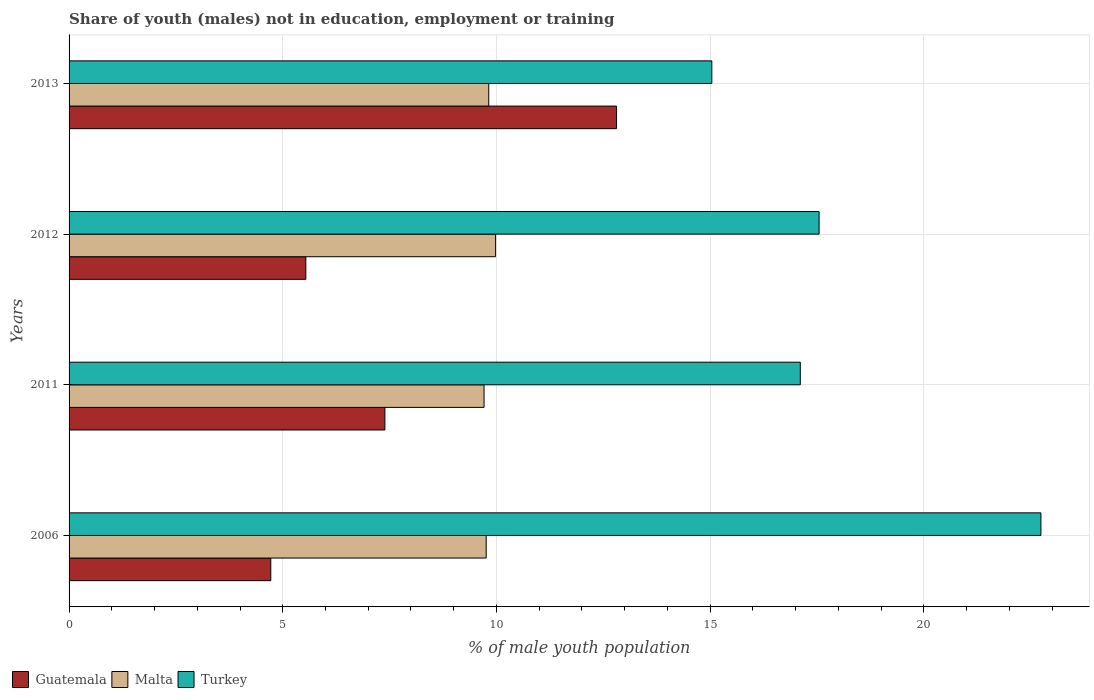How many different coloured bars are there?
Provide a succinct answer. 3. How many groups of bars are there?
Offer a very short reply. 4. What is the label of the 1st group of bars from the top?
Give a very brief answer. 2013. In how many cases, is the number of bars for a given year not equal to the number of legend labels?
Make the answer very short. 0. What is the percentage of unemployed males population in in Guatemala in 2006?
Your answer should be very brief. 4.72. Across all years, what is the maximum percentage of unemployed males population in in Guatemala?
Offer a terse response. 12.81. Across all years, what is the minimum percentage of unemployed males population in in Guatemala?
Ensure brevity in your answer.  4.72. In which year was the percentage of unemployed males population in in Turkey minimum?
Your answer should be very brief. 2013. What is the total percentage of unemployed males population in in Guatemala in the graph?
Make the answer very short. 30.46. What is the difference between the percentage of unemployed males population in in Turkey in 2011 and that in 2013?
Offer a very short reply. 2.07. What is the difference between the percentage of unemployed males population in in Turkey in 2011 and the percentage of unemployed males population in in Guatemala in 2013?
Ensure brevity in your answer.  4.3. What is the average percentage of unemployed males population in in Turkey per year?
Offer a very short reply. 18.11. In the year 2012, what is the difference between the percentage of unemployed males population in in Malta and percentage of unemployed males population in in Guatemala?
Give a very brief answer. 4.44. In how many years, is the percentage of unemployed males population in in Malta greater than 8 %?
Ensure brevity in your answer.  4. What is the ratio of the percentage of unemployed males population in in Turkey in 2011 to that in 2012?
Offer a very short reply. 0.97. What is the difference between the highest and the second highest percentage of unemployed males population in in Guatemala?
Your answer should be very brief. 5.42. What is the difference between the highest and the lowest percentage of unemployed males population in in Malta?
Offer a terse response. 0.27. In how many years, is the percentage of unemployed males population in in Malta greater than the average percentage of unemployed males population in in Malta taken over all years?
Offer a very short reply. 2. What does the 2nd bar from the top in 2012 represents?
Provide a short and direct response. Malta. What does the 2nd bar from the bottom in 2013 represents?
Your response must be concise. Malta. Is it the case that in every year, the sum of the percentage of unemployed males population in in Malta and percentage of unemployed males population in in Turkey is greater than the percentage of unemployed males population in in Guatemala?
Give a very brief answer. Yes. How many bars are there?
Provide a succinct answer. 12. What is the difference between two consecutive major ticks on the X-axis?
Your answer should be very brief. 5. Are the values on the major ticks of X-axis written in scientific E-notation?
Provide a succinct answer. No. Does the graph contain grids?
Keep it short and to the point. Yes. How many legend labels are there?
Your answer should be compact. 3. How are the legend labels stacked?
Offer a terse response. Horizontal. What is the title of the graph?
Your answer should be very brief. Share of youth (males) not in education, employment or training. Does "Togo" appear as one of the legend labels in the graph?
Provide a short and direct response. No. What is the label or title of the X-axis?
Your response must be concise. % of male youth population. What is the label or title of the Y-axis?
Offer a very short reply. Years. What is the % of male youth population of Guatemala in 2006?
Offer a terse response. 4.72. What is the % of male youth population in Malta in 2006?
Your response must be concise. 9.76. What is the % of male youth population in Turkey in 2006?
Provide a short and direct response. 22.74. What is the % of male youth population of Guatemala in 2011?
Your answer should be compact. 7.39. What is the % of male youth population in Malta in 2011?
Offer a terse response. 9.71. What is the % of male youth population of Turkey in 2011?
Provide a succinct answer. 17.11. What is the % of male youth population of Guatemala in 2012?
Provide a succinct answer. 5.54. What is the % of male youth population of Malta in 2012?
Give a very brief answer. 9.98. What is the % of male youth population in Turkey in 2012?
Provide a short and direct response. 17.55. What is the % of male youth population in Guatemala in 2013?
Your answer should be very brief. 12.81. What is the % of male youth population of Malta in 2013?
Keep it short and to the point. 9.82. What is the % of male youth population of Turkey in 2013?
Offer a terse response. 15.04. Across all years, what is the maximum % of male youth population of Guatemala?
Your answer should be very brief. 12.81. Across all years, what is the maximum % of male youth population of Malta?
Your response must be concise. 9.98. Across all years, what is the maximum % of male youth population in Turkey?
Make the answer very short. 22.74. Across all years, what is the minimum % of male youth population of Guatemala?
Offer a very short reply. 4.72. Across all years, what is the minimum % of male youth population of Malta?
Make the answer very short. 9.71. Across all years, what is the minimum % of male youth population of Turkey?
Keep it short and to the point. 15.04. What is the total % of male youth population of Guatemala in the graph?
Your response must be concise. 30.46. What is the total % of male youth population of Malta in the graph?
Ensure brevity in your answer.  39.27. What is the total % of male youth population of Turkey in the graph?
Your response must be concise. 72.44. What is the difference between the % of male youth population of Guatemala in 2006 and that in 2011?
Your answer should be compact. -2.67. What is the difference between the % of male youth population of Turkey in 2006 and that in 2011?
Give a very brief answer. 5.63. What is the difference between the % of male youth population of Guatemala in 2006 and that in 2012?
Your response must be concise. -0.82. What is the difference between the % of male youth population of Malta in 2006 and that in 2012?
Give a very brief answer. -0.22. What is the difference between the % of male youth population in Turkey in 2006 and that in 2012?
Make the answer very short. 5.19. What is the difference between the % of male youth population of Guatemala in 2006 and that in 2013?
Provide a short and direct response. -8.09. What is the difference between the % of male youth population in Malta in 2006 and that in 2013?
Your answer should be very brief. -0.06. What is the difference between the % of male youth population in Turkey in 2006 and that in 2013?
Give a very brief answer. 7.7. What is the difference between the % of male youth population of Guatemala in 2011 and that in 2012?
Make the answer very short. 1.85. What is the difference between the % of male youth population of Malta in 2011 and that in 2012?
Make the answer very short. -0.27. What is the difference between the % of male youth population of Turkey in 2011 and that in 2012?
Give a very brief answer. -0.44. What is the difference between the % of male youth population of Guatemala in 2011 and that in 2013?
Provide a succinct answer. -5.42. What is the difference between the % of male youth population of Malta in 2011 and that in 2013?
Give a very brief answer. -0.11. What is the difference between the % of male youth population in Turkey in 2011 and that in 2013?
Your response must be concise. 2.07. What is the difference between the % of male youth population in Guatemala in 2012 and that in 2013?
Offer a very short reply. -7.27. What is the difference between the % of male youth population of Malta in 2012 and that in 2013?
Give a very brief answer. 0.16. What is the difference between the % of male youth population in Turkey in 2012 and that in 2013?
Offer a terse response. 2.51. What is the difference between the % of male youth population of Guatemala in 2006 and the % of male youth population of Malta in 2011?
Make the answer very short. -4.99. What is the difference between the % of male youth population in Guatemala in 2006 and the % of male youth population in Turkey in 2011?
Ensure brevity in your answer.  -12.39. What is the difference between the % of male youth population of Malta in 2006 and the % of male youth population of Turkey in 2011?
Offer a very short reply. -7.35. What is the difference between the % of male youth population in Guatemala in 2006 and the % of male youth population in Malta in 2012?
Offer a very short reply. -5.26. What is the difference between the % of male youth population in Guatemala in 2006 and the % of male youth population in Turkey in 2012?
Your response must be concise. -12.83. What is the difference between the % of male youth population in Malta in 2006 and the % of male youth population in Turkey in 2012?
Ensure brevity in your answer.  -7.79. What is the difference between the % of male youth population in Guatemala in 2006 and the % of male youth population in Malta in 2013?
Ensure brevity in your answer.  -5.1. What is the difference between the % of male youth population in Guatemala in 2006 and the % of male youth population in Turkey in 2013?
Provide a succinct answer. -10.32. What is the difference between the % of male youth population of Malta in 2006 and the % of male youth population of Turkey in 2013?
Give a very brief answer. -5.28. What is the difference between the % of male youth population in Guatemala in 2011 and the % of male youth population in Malta in 2012?
Provide a succinct answer. -2.59. What is the difference between the % of male youth population in Guatemala in 2011 and the % of male youth population in Turkey in 2012?
Keep it short and to the point. -10.16. What is the difference between the % of male youth population in Malta in 2011 and the % of male youth population in Turkey in 2012?
Provide a succinct answer. -7.84. What is the difference between the % of male youth population in Guatemala in 2011 and the % of male youth population in Malta in 2013?
Your response must be concise. -2.43. What is the difference between the % of male youth population of Guatemala in 2011 and the % of male youth population of Turkey in 2013?
Offer a very short reply. -7.65. What is the difference between the % of male youth population in Malta in 2011 and the % of male youth population in Turkey in 2013?
Offer a very short reply. -5.33. What is the difference between the % of male youth population in Guatemala in 2012 and the % of male youth population in Malta in 2013?
Provide a succinct answer. -4.28. What is the difference between the % of male youth population of Malta in 2012 and the % of male youth population of Turkey in 2013?
Make the answer very short. -5.06. What is the average % of male youth population of Guatemala per year?
Provide a short and direct response. 7.62. What is the average % of male youth population of Malta per year?
Ensure brevity in your answer.  9.82. What is the average % of male youth population in Turkey per year?
Offer a terse response. 18.11. In the year 2006, what is the difference between the % of male youth population of Guatemala and % of male youth population of Malta?
Provide a short and direct response. -5.04. In the year 2006, what is the difference between the % of male youth population of Guatemala and % of male youth population of Turkey?
Your answer should be compact. -18.02. In the year 2006, what is the difference between the % of male youth population of Malta and % of male youth population of Turkey?
Provide a short and direct response. -12.98. In the year 2011, what is the difference between the % of male youth population in Guatemala and % of male youth population in Malta?
Ensure brevity in your answer.  -2.32. In the year 2011, what is the difference between the % of male youth population of Guatemala and % of male youth population of Turkey?
Offer a terse response. -9.72. In the year 2011, what is the difference between the % of male youth population in Malta and % of male youth population in Turkey?
Your response must be concise. -7.4. In the year 2012, what is the difference between the % of male youth population in Guatemala and % of male youth population in Malta?
Your answer should be compact. -4.44. In the year 2012, what is the difference between the % of male youth population of Guatemala and % of male youth population of Turkey?
Provide a short and direct response. -12.01. In the year 2012, what is the difference between the % of male youth population in Malta and % of male youth population in Turkey?
Keep it short and to the point. -7.57. In the year 2013, what is the difference between the % of male youth population of Guatemala and % of male youth population of Malta?
Your answer should be very brief. 2.99. In the year 2013, what is the difference between the % of male youth population in Guatemala and % of male youth population in Turkey?
Your answer should be very brief. -2.23. In the year 2013, what is the difference between the % of male youth population of Malta and % of male youth population of Turkey?
Make the answer very short. -5.22. What is the ratio of the % of male youth population in Guatemala in 2006 to that in 2011?
Offer a terse response. 0.64. What is the ratio of the % of male youth population in Malta in 2006 to that in 2011?
Your answer should be very brief. 1.01. What is the ratio of the % of male youth population of Turkey in 2006 to that in 2011?
Offer a terse response. 1.33. What is the ratio of the % of male youth population of Guatemala in 2006 to that in 2012?
Your answer should be very brief. 0.85. What is the ratio of the % of male youth population in Turkey in 2006 to that in 2012?
Offer a terse response. 1.3. What is the ratio of the % of male youth population in Guatemala in 2006 to that in 2013?
Offer a terse response. 0.37. What is the ratio of the % of male youth population of Malta in 2006 to that in 2013?
Make the answer very short. 0.99. What is the ratio of the % of male youth population of Turkey in 2006 to that in 2013?
Keep it short and to the point. 1.51. What is the ratio of the % of male youth population in Guatemala in 2011 to that in 2012?
Your response must be concise. 1.33. What is the ratio of the % of male youth population of Malta in 2011 to that in 2012?
Your answer should be very brief. 0.97. What is the ratio of the % of male youth population in Turkey in 2011 to that in 2012?
Your response must be concise. 0.97. What is the ratio of the % of male youth population of Guatemala in 2011 to that in 2013?
Provide a short and direct response. 0.58. What is the ratio of the % of male youth population in Turkey in 2011 to that in 2013?
Give a very brief answer. 1.14. What is the ratio of the % of male youth population of Guatemala in 2012 to that in 2013?
Provide a short and direct response. 0.43. What is the ratio of the % of male youth population in Malta in 2012 to that in 2013?
Provide a succinct answer. 1.02. What is the ratio of the % of male youth population of Turkey in 2012 to that in 2013?
Your response must be concise. 1.17. What is the difference between the highest and the second highest % of male youth population in Guatemala?
Ensure brevity in your answer.  5.42. What is the difference between the highest and the second highest % of male youth population in Malta?
Ensure brevity in your answer.  0.16. What is the difference between the highest and the second highest % of male youth population of Turkey?
Make the answer very short. 5.19. What is the difference between the highest and the lowest % of male youth population of Guatemala?
Ensure brevity in your answer.  8.09. What is the difference between the highest and the lowest % of male youth population in Malta?
Provide a short and direct response. 0.27. What is the difference between the highest and the lowest % of male youth population in Turkey?
Your answer should be very brief. 7.7. 